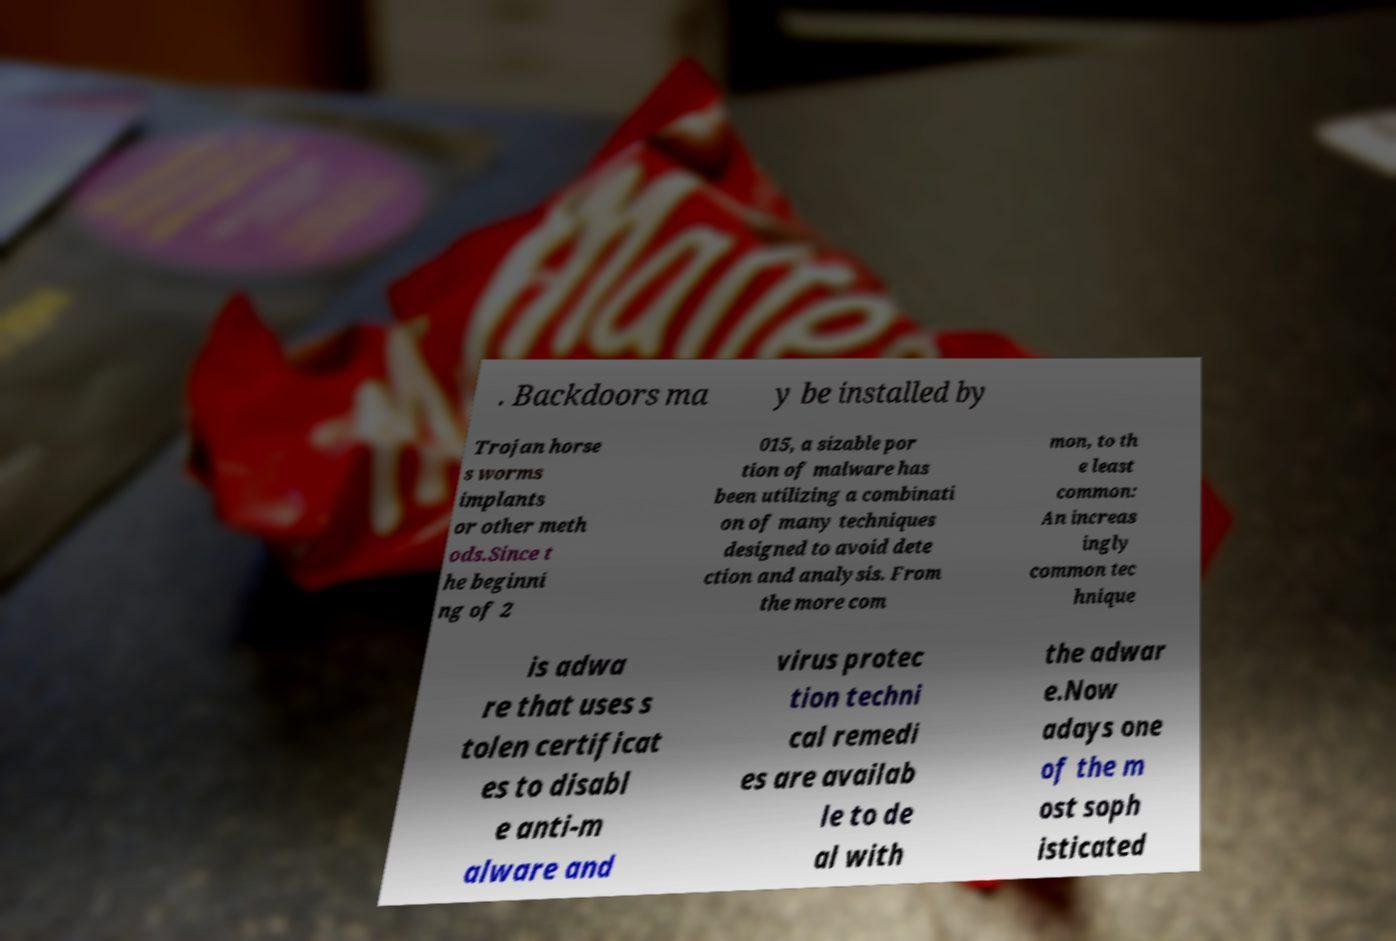There's text embedded in this image that I need extracted. Can you transcribe it verbatim? . Backdoors ma y be installed by Trojan horse s worms implants or other meth ods.Since t he beginni ng of 2 015, a sizable por tion of malware has been utilizing a combinati on of many techniques designed to avoid dete ction and analysis. From the more com mon, to th e least common: An increas ingly common tec hnique is adwa re that uses s tolen certificat es to disabl e anti-m alware and virus protec tion techni cal remedi es are availab le to de al with the adwar e.Now adays one of the m ost soph isticated 